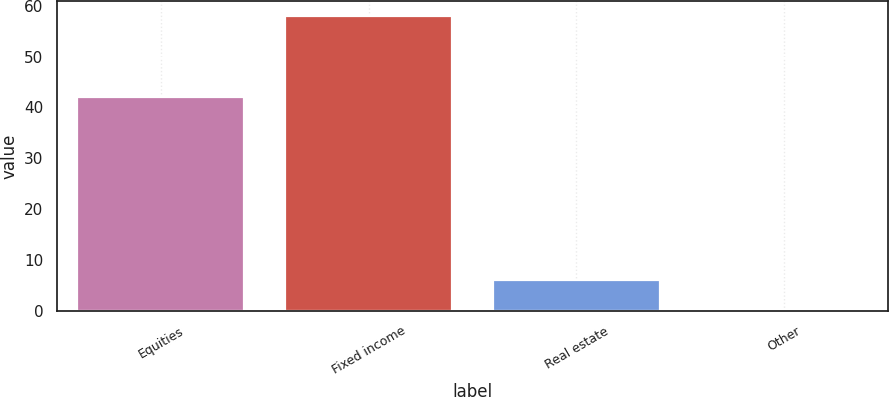Convert chart to OTSL. <chart><loc_0><loc_0><loc_500><loc_500><bar_chart><fcel>Equities<fcel>Fixed income<fcel>Real estate<fcel>Other<nl><fcel>42<fcel>58<fcel>6.11<fcel>0.34<nl></chart> 